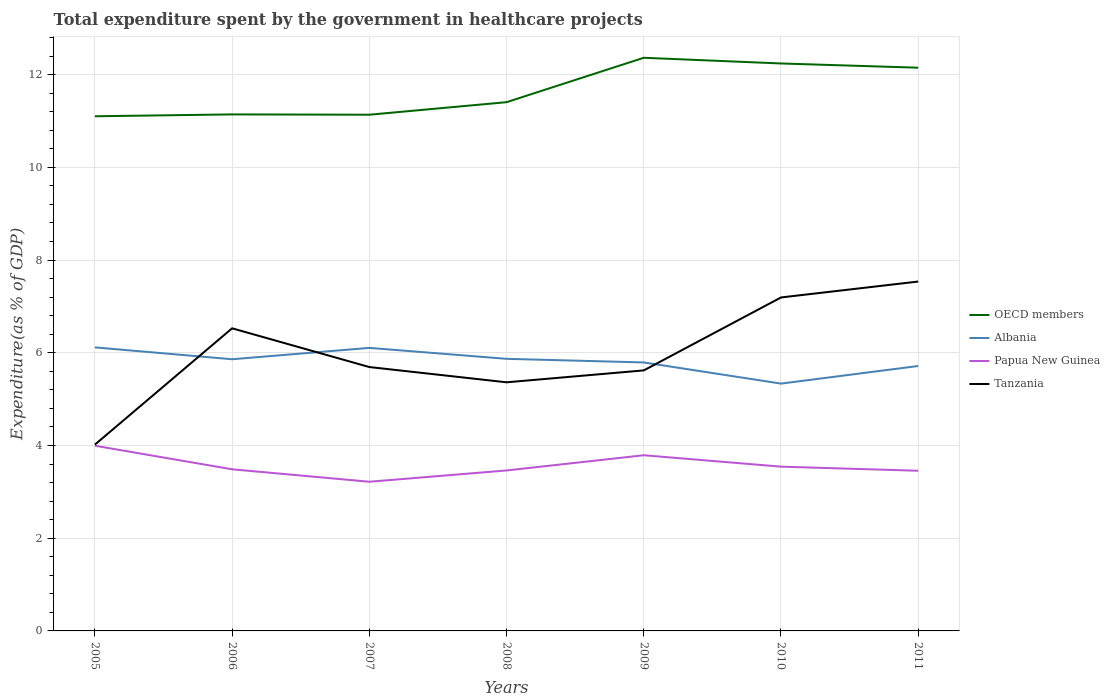How many different coloured lines are there?
Provide a succinct answer. 4. Does the line corresponding to Albania intersect with the line corresponding to Papua New Guinea?
Provide a succinct answer. No. Across all years, what is the maximum total expenditure spent by the government in healthcare projects in OECD members?
Offer a terse response. 11.1. In which year was the total expenditure spent by the government in healthcare projects in Tanzania maximum?
Provide a succinct answer. 2005. What is the total total expenditure spent by the government in healthcare projects in Papua New Guinea in the graph?
Make the answer very short. 0.27. What is the difference between the highest and the second highest total expenditure spent by the government in healthcare projects in Papua New Guinea?
Your response must be concise. 0.78. What is the difference between the highest and the lowest total expenditure spent by the government in healthcare projects in Albania?
Offer a terse response. 4. Is the total expenditure spent by the government in healthcare projects in Tanzania strictly greater than the total expenditure spent by the government in healthcare projects in Papua New Guinea over the years?
Your response must be concise. No. How many years are there in the graph?
Your answer should be very brief. 7. Does the graph contain any zero values?
Make the answer very short. No. Where does the legend appear in the graph?
Make the answer very short. Center right. How are the legend labels stacked?
Offer a terse response. Vertical. What is the title of the graph?
Provide a succinct answer. Total expenditure spent by the government in healthcare projects. Does "Guatemala" appear as one of the legend labels in the graph?
Your answer should be very brief. No. What is the label or title of the Y-axis?
Your answer should be very brief. Expenditure(as % of GDP). What is the Expenditure(as % of GDP) of OECD members in 2005?
Give a very brief answer. 11.1. What is the Expenditure(as % of GDP) of Albania in 2005?
Offer a very short reply. 6.12. What is the Expenditure(as % of GDP) in Papua New Guinea in 2005?
Your answer should be very brief. 3.99. What is the Expenditure(as % of GDP) in Tanzania in 2005?
Provide a short and direct response. 4.02. What is the Expenditure(as % of GDP) in OECD members in 2006?
Your answer should be very brief. 11.14. What is the Expenditure(as % of GDP) in Albania in 2006?
Ensure brevity in your answer.  5.86. What is the Expenditure(as % of GDP) in Papua New Guinea in 2006?
Provide a short and direct response. 3.49. What is the Expenditure(as % of GDP) in Tanzania in 2006?
Provide a succinct answer. 6.53. What is the Expenditure(as % of GDP) in OECD members in 2007?
Make the answer very short. 11.13. What is the Expenditure(as % of GDP) of Albania in 2007?
Give a very brief answer. 6.11. What is the Expenditure(as % of GDP) of Papua New Guinea in 2007?
Your response must be concise. 3.22. What is the Expenditure(as % of GDP) in Tanzania in 2007?
Provide a short and direct response. 5.69. What is the Expenditure(as % of GDP) in OECD members in 2008?
Your answer should be compact. 11.41. What is the Expenditure(as % of GDP) of Albania in 2008?
Your answer should be compact. 5.87. What is the Expenditure(as % of GDP) in Papua New Guinea in 2008?
Offer a very short reply. 3.46. What is the Expenditure(as % of GDP) of Tanzania in 2008?
Provide a short and direct response. 5.36. What is the Expenditure(as % of GDP) of OECD members in 2009?
Your answer should be compact. 12.36. What is the Expenditure(as % of GDP) of Albania in 2009?
Keep it short and to the point. 5.79. What is the Expenditure(as % of GDP) of Papua New Guinea in 2009?
Give a very brief answer. 3.79. What is the Expenditure(as % of GDP) in Tanzania in 2009?
Provide a succinct answer. 5.62. What is the Expenditure(as % of GDP) of OECD members in 2010?
Your answer should be very brief. 12.24. What is the Expenditure(as % of GDP) in Albania in 2010?
Make the answer very short. 5.34. What is the Expenditure(as % of GDP) of Papua New Guinea in 2010?
Keep it short and to the point. 3.54. What is the Expenditure(as % of GDP) in Tanzania in 2010?
Your answer should be very brief. 7.19. What is the Expenditure(as % of GDP) in OECD members in 2011?
Provide a succinct answer. 12.15. What is the Expenditure(as % of GDP) in Albania in 2011?
Your response must be concise. 5.71. What is the Expenditure(as % of GDP) of Papua New Guinea in 2011?
Offer a terse response. 3.46. What is the Expenditure(as % of GDP) of Tanzania in 2011?
Keep it short and to the point. 7.54. Across all years, what is the maximum Expenditure(as % of GDP) of OECD members?
Your response must be concise. 12.36. Across all years, what is the maximum Expenditure(as % of GDP) of Albania?
Give a very brief answer. 6.12. Across all years, what is the maximum Expenditure(as % of GDP) of Papua New Guinea?
Make the answer very short. 3.99. Across all years, what is the maximum Expenditure(as % of GDP) of Tanzania?
Your answer should be very brief. 7.54. Across all years, what is the minimum Expenditure(as % of GDP) of OECD members?
Offer a very short reply. 11.1. Across all years, what is the minimum Expenditure(as % of GDP) of Albania?
Offer a very short reply. 5.34. Across all years, what is the minimum Expenditure(as % of GDP) of Papua New Guinea?
Your answer should be compact. 3.22. Across all years, what is the minimum Expenditure(as % of GDP) of Tanzania?
Make the answer very short. 4.02. What is the total Expenditure(as % of GDP) in OECD members in the graph?
Give a very brief answer. 81.54. What is the total Expenditure(as % of GDP) in Albania in the graph?
Give a very brief answer. 40.79. What is the total Expenditure(as % of GDP) in Papua New Guinea in the graph?
Your response must be concise. 24.95. What is the total Expenditure(as % of GDP) in Tanzania in the graph?
Your response must be concise. 41.95. What is the difference between the Expenditure(as % of GDP) of OECD members in 2005 and that in 2006?
Your response must be concise. -0.04. What is the difference between the Expenditure(as % of GDP) of Albania in 2005 and that in 2006?
Your answer should be compact. 0.26. What is the difference between the Expenditure(as % of GDP) in Papua New Guinea in 2005 and that in 2006?
Make the answer very short. 0.51. What is the difference between the Expenditure(as % of GDP) in Tanzania in 2005 and that in 2006?
Give a very brief answer. -2.51. What is the difference between the Expenditure(as % of GDP) in OECD members in 2005 and that in 2007?
Provide a succinct answer. -0.03. What is the difference between the Expenditure(as % of GDP) of Albania in 2005 and that in 2007?
Provide a succinct answer. 0.01. What is the difference between the Expenditure(as % of GDP) in Papua New Guinea in 2005 and that in 2007?
Your answer should be very brief. 0.78. What is the difference between the Expenditure(as % of GDP) of Tanzania in 2005 and that in 2007?
Provide a short and direct response. -1.67. What is the difference between the Expenditure(as % of GDP) in OECD members in 2005 and that in 2008?
Your answer should be very brief. -0.3. What is the difference between the Expenditure(as % of GDP) in Albania in 2005 and that in 2008?
Provide a succinct answer. 0.25. What is the difference between the Expenditure(as % of GDP) in Papua New Guinea in 2005 and that in 2008?
Give a very brief answer. 0.53. What is the difference between the Expenditure(as % of GDP) of Tanzania in 2005 and that in 2008?
Keep it short and to the point. -1.34. What is the difference between the Expenditure(as % of GDP) of OECD members in 2005 and that in 2009?
Your answer should be compact. -1.26. What is the difference between the Expenditure(as % of GDP) in Albania in 2005 and that in 2009?
Your answer should be compact. 0.32. What is the difference between the Expenditure(as % of GDP) of Papua New Guinea in 2005 and that in 2009?
Your answer should be very brief. 0.21. What is the difference between the Expenditure(as % of GDP) in Tanzania in 2005 and that in 2009?
Your answer should be compact. -1.6. What is the difference between the Expenditure(as % of GDP) of OECD members in 2005 and that in 2010?
Make the answer very short. -1.14. What is the difference between the Expenditure(as % of GDP) in Albania in 2005 and that in 2010?
Offer a terse response. 0.78. What is the difference between the Expenditure(as % of GDP) in Papua New Guinea in 2005 and that in 2010?
Ensure brevity in your answer.  0.45. What is the difference between the Expenditure(as % of GDP) of Tanzania in 2005 and that in 2010?
Offer a very short reply. -3.17. What is the difference between the Expenditure(as % of GDP) in OECD members in 2005 and that in 2011?
Offer a very short reply. -1.05. What is the difference between the Expenditure(as % of GDP) in Albania in 2005 and that in 2011?
Keep it short and to the point. 0.4. What is the difference between the Expenditure(as % of GDP) in Papua New Guinea in 2005 and that in 2011?
Your answer should be very brief. 0.54. What is the difference between the Expenditure(as % of GDP) of Tanzania in 2005 and that in 2011?
Offer a very short reply. -3.52. What is the difference between the Expenditure(as % of GDP) of OECD members in 2006 and that in 2007?
Your answer should be compact. 0.01. What is the difference between the Expenditure(as % of GDP) in Albania in 2006 and that in 2007?
Your response must be concise. -0.24. What is the difference between the Expenditure(as % of GDP) in Papua New Guinea in 2006 and that in 2007?
Make the answer very short. 0.27. What is the difference between the Expenditure(as % of GDP) in Tanzania in 2006 and that in 2007?
Make the answer very short. 0.84. What is the difference between the Expenditure(as % of GDP) in OECD members in 2006 and that in 2008?
Offer a very short reply. -0.26. What is the difference between the Expenditure(as % of GDP) in Albania in 2006 and that in 2008?
Your answer should be very brief. -0.01. What is the difference between the Expenditure(as % of GDP) of Papua New Guinea in 2006 and that in 2008?
Provide a succinct answer. 0.03. What is the difference between the Expenditure(as % of GDP) in Tanzania in 2006 and that in 2008?
Ensure brevity in your answer.  1.16. What is the difference between the Expenditure(as % of GDP) in OECD members in 2006 and that in 2009?
Offer a terse response. -1.22. What is the difference between the Expenditure(as % of GDP) in Albania in 2006 and that in 2009?
Offer a terse response. 0.07. What is the difference between the Expenditure(as % of GDP) of Papua New Guinea in 2006 and that in 2009?
Give a very brief answer. -0.3. What is the difference between the Expenditure(as % of GDP) in Tanzania in 2006 and that in 2009?
Offer a very short reply. 0.91. What is the difference between the Expenditure(as % of GDP) in OECD members in 2006 and that in 2010?
Your answer should be very brief. -1.1. What is the difference between the Expenditure(as % of GDP) in Albania in 2006 and that in 2010?
Keep it short and to the point. 0.53. What is the difference between the Expenditure(as % of GDP) in Papua New Guinea in 2006 and that in 2010?
Make the answer very short. -0.06. What is the difference between the Expenditure(as % of GDP) of Tanzania in 2006 and that in 2010?
Offer a terse response. -0.67. What is the difference between the Expenditure(as % of GDP) in OECD members in 2006 and that in 2011?
Offer a terse response. -1.01. What is the difference between the Expenditure(as % of GDP) in Albania in 2006 and that in 2011?
Provide a succinct answer. 0.15. What is the difference between the Expenditure(as % of GDP) in Papua New Guinea in 2006 and that in 2011?
Offer a terse response. 0.03. What is the difference between the Expenditure(as % of GDP) of Tanzania in 2006 and that in 2011?
Your response must be concise. -1.01. What is the difference between the Expenditure(as % of GDP) in OECD members in 2007 and that in 2008?
Give a very brief answer. -0.27. What is the difference between the Expenditure(as % of GDP) in Albania in 2007 and that in 2008?
Give a very brief answer. 0.24. What is the difference between the Expenditure(as % of GDP) of Papua New Guinea in 2007 and that in 2008?
Your answer should be very brief. -0.24. What is the difference between the Expenditure(as % of GDP) of Tanzania in 2007 and that in 2008?
Your response must be concise. 0.33. What is the difference between the Expenditure(as % of GDP) of OECD members in 2007 and that in 2009?
Your answer should be compact. -1.23. What is the difference between the Expenditure(as % of GDP) of Albania in 2007 and that in 2009?
Ensure brevity in your answer.  0.31. What is the difference between the Expenditure(as % of GDP) of Papua New Guinea in 2007 and that in 2009?
Make the answer very short. -0.57. What is the difference between the Expenditure(as % of GDP) in Tanzania in 2007 and that in 2009?
Give a very brief answer. 0.07. What is the difference between the Expenditure(as % of GDP) in OECD members in 2007 and that in 2010?
Ensure brevity in your answer.  -1.11. What is the difference between the Expenditure(as % of GDP) in Albania in 2007 and that in 2010?
Provide a short and direct response. 0.77. What is the difference between the Expenditure(as % of GDP) of Papua New Guinea in 2007 and that in 2010?
Offer a terse response. -0.33. What is the difference between the Expenditure(as % of GDP) of Tanzania in 2007 and that in 2010?
Your response must be concise. -1.5. What is the difference between the Expenditure(as % of GDP) of OECD members in 2007 and that in 2011?
Ensure brevity in your answer.  -1.01. What is the difference between the Expenditure(as % of GDP) in Albania in 2007 and that in 2011?
Make the answer very short. 0.39. What is the difference between the Expenditure(as % of GDP) in Papua New Guinea in 2007 and that in 2011?
Offer a terse response. -0.24. What is the difference between the Expenditure(as % of GDP) of Tanzania in 2007 and that in 2011?
Ensure brevity in your answer.  -1.84. What is the difference between the Expenditure(as % of GDP) of OECD members in 2008 and that in 2009?
Your answer should be very brief. -0.96. What is the difference between the Expenditure(as % of GDP) in Albania in 2008 and that in 2009?
Give a very brief answer. 0.08. What is the difference between the Expenditure(as % of GDP) in Papua New Guinea in 2008 and that in 2009?
Your answer should be very brief. -0.33. What is the difference between the Expenditure(as % of GDP) in Tanzania in 2008 and that in 2009?
Ensure brevity in your answer.  -0.26. What is the difference between the Expenditure(as % of GDP) in OECD members in 2008 and that in 2010?
Give a very brief answer. -0.83. What is the difference between the Expenditure(as % of GDP) in Albania in 2008 and that in 2010?
Your answer should be very brief. 0.53. What is the difference between the Expenditure(as % of GDP) in Papua New Guinea in 2008 and that in 2010?
Your answer should be very brief. -0.08. What is the difference between the Expenditure(as % of GDP) in Tanzania in 2008 and that in 2010?
Offer a very short reply. -1.83. What is the difference between the Expenditure(as % of GDP) in OECD members in 2008 and that in 2011?
Ensure brevity in your answer.  -0.74. What is the difference between the Expenditure(as % of GDP) of Albania in 2008 and that in 2011?
Make the answer very short. 0.15. What is the difference between the Expenditure(as % of GDP) in Papua New Guinea in 2008 and that in 2011?
Provide a succinct answer. 0.01. What is the difference between the Expenditure(as % of GDP) in Tanzania in 2008 and that in 2011?
Your answer should be compact. -2.17. What is the difference between the Expenditure(as % of GDP) of OECD members in 2009 and that in 2010?
Ensure brevity in your answer.  0.12. What is the difference between the Expenditure(as % of GDP) in Albania in 2009 and that in 2010?
Your answer should be compact. 0.46. What is the difference between the Expenditure(as % of GDP) of Papua New Guinea in 2009 and that in 2010?
Your answer should be compact. 0.25. What is the difference between the Expenditure(as % of GDP) in Tanzania in 2009 and that in 2010?
Your response must be concise. -1.57. What is the difference between the Expenditure(as % of GDP) in OECD members in 2009 and that in 2011?
Provide a succinct answer. 0.21. What is the difference between the Expenditure(as % of GDP) of Albania in 2009 and that in 2011?
Keep it short and to the point. 0.08. What is the difference between the Expenditure(as % of GDP) in Papua New Guinea in 2009 and that in 2011?
Your answer should be very brief. 0.33. What is the difference between the Expenditure(as % of GDP) in Tanzania in 2009 and that in 2011?
Keep it short and to the point. -1.92. What is the difference between the Expenditure(as % of GDP) in OECD members in 2010 and that in 2011?
Offer a terse response. 0.09. What is the difference between the Expenditure(as % of GDP) in Albania in 2010 and that in 2011?
Make the answer very short. -0.38. What is the difference between the Expenditure(as % of GDP) in Papua New Guinea in 2010 and that in 2011?
Make the answer very short. 0.09. What is the difference between the Expenditure(as % of GDP) of Tanzania in 2010 and that in 2011?
Offer a terse response. -0.34. What is the difference between the Expenditure(as % of GDP) of OECD members in 2005 and the Expenditure(as % of GDP) of Albania in 2006?
Keep it short and to the point. 5.24. What is the difference between the Expenditure(as % of GDP) of OECD members in 2005 and the Expenditure(as % of GDP) of Papua New Guinea in 2006?
Offer a very short reply. 7.62. What is the difference between the Expenditure(as % of GDP) of OECD members in 2005 and the Expenditure(as % of GDP) of Tanzania in 2006?
Keep it short and to the point. 4.57. What is the difference between the Expenditure(as % of GDP) in Albania in 2005 and the Expenditure(as % of GDP) in Papua New Guinea in 2006?
Offer a terse response. 2.63. What is the difference between the Expenditure(as % of GDP) in Albania in 2005 and the Expenditure(as % of GDP) in Tanzania in 2006?
Provide a short and direct response. -0.41. What is the difference between the Expenditure(as % of GDP) in Papua New Guinea in 2005 and the Expenditure(as % of GDP) in Tanzania in 2006?
Your answer should be very brief. -2.53. What is the difference between the Expenditure(as % of GDP) of OECD members in 2005 and the Expenditure(as % of GDP) of Albania in 2007?
Keep it short and to the point. 5. What is the difference between the Expenditure(as % of GDP) in OECD members in 2005 and the Expenditure(as % of GDP) in Papua New Guinea in 2007?
Offer a very short reply. 7.88. What is the difference between the Expenditure(as % of GDP) of OECD members in 2005 and the Expenditure(as % of GDP) of Tanzania in 2007?
Your response must be concise. 5.41. What is the difference between the Expenditure(as % of GDP) in Albania in 2005 and the Expenditure(as % of GDP) in Papua New Guinea in 2007?
Keep it short and to the point. 2.9. What is the difference between the Expenditure(as % of GDP) of Albania in 2005 and the Expenditure(as % of GDP) of Tanzania in 2007?
Offer a very short reply. 0.42. What is the difference between the Expenditure(as % of GDP) of Papua New Guinea in 2005 and the Expenditure(as % of GDP) of Tanzania in 2007?
Make the answer very short. -1.7. What is the difference between the Expenditure(as % of GDP) in OECD members in 2005 and the Expenditure(as % of GDP) in Albania in 2008?
Provide a succinct answer. 5.23. What is the difference between the Expenditure(as % of GDP) in OECD members in 2005 and the Expenditure(as % of GDP) in Papua New Guinea in 2008?
Make the answer very short. 7.64. What is the difference between the Expenditure(as % of GDP) in OECD members in 2005 and the Expenditure(as % of GDP) in Tanzania in 2008?
Your answer should be compact. 5.74. What is the difference between the Expenditure(as % of GDP) of Albania in 2005 and the Expenditure(as % of GDP) of Papua New Guinea in 2008?
Make the answer very short. 2.65. What is the difference between the Expenditure(as % of GDP) of Albania in 2005 and the Expenditure(as % of GDP) of Tanzania in 2008?
Your answer should be very brief. 0.75. What is the difference between the Expenditure(as % of GDP) of Papua New Guinea in 2005 and the Expenditure(as % of GDP) of Tanzania in 2008?
Give a very brief answer. -1.37. What is the difference between the Expenditure(as % of GDP) of OECD members in 2005 and the Expenditure(as % of GDP) of Albania in 2009?
Offer a terse response. 5.31. What is the difference between the Expenditure(as % of GDP) of OECD members in 2005 and the Expenditure(as % of GDP) of Papua New Guinea in 2009?
Provide a short and direct response. 7.31. What is the difference between the Expenditure(as % of GDP) of OECD members in 2005 and the Expenditure(as % of GDP) of Tanzania in 2009?
Offer a very short reply. 5.48. What is the difference between the Expenditure(as % of GDP) in Albania in 2005 and the Expenditure(as % of GDP) in Papua New Guinea in 2009?
Your response must be concise. 2.33. What is the difference between the Expenditure(as % of GDP) of Albania in 2005 and the Expenditure(as % of GDP) of Tanzania in 2009?
Make the answer very short. 0.5. What is the difference between the Expenditure(as % of GDP) in Papua New Guinea in 2005 and the Expenditure(as % of GDP) in Tanzania in 2009?
Your answer should be compact. -1.62. What is the difference between the Expenditure(as % of GDP) of OECD members in 2005 and the Expenditure(as % of GDP) of Albania in 2010?
Offer a terse response. 5.77. What is the difference between the Expenditure(as % of GDP) of OECD members in 2005 and the Expenditure(as % of GDP) of Papua New Guinea in 2010?
Keep it short and to the point. 7.56. What is the difference between the Expenditure(as % of GDP) of OECD members in 2005 and the Expenditure(as % of GDP) of Tanzania in 2010?
Give a very brief answer. 3.91. What is the difference between the Expenditure(as % of GDP) in Albania in 2005 and the Expenditure(as % of GDP) in Papua New Guinea in 2010?
Keep it short and to the point. 2.57. What is the difference between the Expenditure(as % of GDP) of Albania in 2005 and the Expenditure(as % of GDP) of Tanzania in 2010?
Ensure brevity in your answer.  -1.08. What is the difference between the Expenditure(as % of GDP) of Papua New Guinea in 2005 and the Expenditure(as % of GDP) of Tanzania in 2010?
Ensure brevity in your answer.  -3.2. What is the difference between the Expenditure(as % of GDP) of OECD members in 2005 and the Expenditure(as % of GDP) of Albania in 2011?
Provide a succinct answer. 5.39. What is the difference between the Expenditure(as % of GDP) in OECD members in 2005 and the Expenditure(as % of GDP) in Papua New Guinea in 2011?
Your answer should be compact. 7.65. What is the difference between the Expenditure(as % of GDP) in OECD members in 2005 and the Expenditure(as % of GDP) in Tanzania in 2011?
Ensure brevity in your answer.  3.56. What is the difference between the Expenditure(as % of GDP) of Albania in 2005 and the Expenditure(as % of GDP) of Papua New Guinea in 2011?
Provide a succinct answer. 2.66. What is the difference between the Expenditure(as % of GDP) of Albania in 2005 and the Expenditure(as % of GDP) of Tanzania in 2011?
Make the answer very short. -1.42. What is the difference between the Expenditure(as % of GDP) in Papua New Guinea in 2005 and the Expenditure(as % of GDP) in Tanzania in 2011?
Make the answer very short. -3.54. What is the difference between the Expenditure(as % of GDP) of OECD members in 2006 and the Expenditure(as % of GDP) of Albania in 2007?
Offer a very short reply. 5.04. What is the difference between the Expenditure(as % of GDP) in OECD members in 2006 and the Expenditure(as % of GDP) in Papua New Guinea in 2007?
Your answer should be compact. 7.92. What is the difference between the Expenditure(as % of GDP) of OECD members in 2006 and the Expenditure(as % of GDP) of Tanzania in 2007?
Your answer should be compact. 5.45. What is the difference between the Expenditure(as % of GDP) in Albania in 2006 and the Expenditure(as % of GDP) in Papua New Guinea in 2007?
Offer a very short reply. 2.64. What is the difference between the Expenditure(as % of GDP) in Albania in 2006 and the Expenditure(as % of GDP) in Tanzania in 2007?
Ensure brevity in your answer.  0.17. What is the difference between the Expenditure(as % of GDP) of Papua New Guinea in 2006 and the Expenditure(as % of GDP) of Tanzania in 2007?
Make the answer very short. -2.21. What is the difference between the Expenditure(as % of GDP) of OECD members in 2006 and the Expenditure(as % of GDP) of Albania in 2008?
Offer a terse response. 5.27. What is the difference between the Expenditure(as % of GDP) of OECD members in 2006 and the Expenditure(as % of GDP) of Papua New Guinea in 2008?
Your answer should be compact. 7.68. What is the difference between the Expenditure(as % of GDP) in OECD members in 2006 and the Expenditure(as % of GDP) in Tanzania in 2008?
Ensure brevity in your answer.  5.78. What is the difference between the Expenditure(as % of GDP) in Albania in 2006 and the Expenditure(as % of GDP) in Papua New Guinea in 2008?
Your answer should be very brief. 2.4. What is the difference between the Expenditure(as % of GDP) in Albania in 2006 and the Expenditure(as % of GDP) in Tanzania in 2008?
Offer a terse response. 0.5. What is the difference between the Expenditure(as % of GDP) in Papua New Guinea in 2006 and the Expenditure(as % of GDP) in Tanzania in 2008?
Make the answer very short. -1.88. What is the difference between the Expenditure(as % of GDP) in OECD members in 2006 and the Expenditure(as % of GDP) in Albania in 2009?
Give a very brief answer. 5.35. What is the difference between the Expenditure(as % of GDP) in OECD members in 2006 and the Expenditure(as % of GDP) in Papua New Guinea in 2009?
Provide a succinct answer. 7.35. What is the difference between the Expenditure(as % of GDP) in OECD members in 2006 and the Expenditure(as % of GDP) in Tanzania in 2009?
Offer a very short reply. 5.52. What is the difference between the Expenditure(as % of GDP) of Albania in 2006 and the Expenditure(as % of GDP) of Papua New Guinea in 2009?
Ensure brevity in your answer.  2.07. What is the difference between the Expenditure(as % of GDP) in Albania in 2006 and the Expenditure(as % of GDP) in Tanzania in 2009?
Provide a succinct answer. 0.24. What is the difference between the Expenditure(as % of GDP) in Papua New Guinea in 2006 and the Expenditure(as % of GDP) in Tanzania in 2009?
Ensure brevity in your answer.  -2.13. What is the difference between the Expenditure(as % of GDP) of OECD members in 2006 and the Expenditure(as % of GDP) of Albania in 2010?
Give a very brief answer. 5.81. What is the difference between the Expenditure(as % of GDP) in OECD members in 2006 and the Expenditure(as % of GDP) in Papua New Guinea in 2010?
Provide a succinct answer. 7.6. What is the difference between the Expenditure(as % of GDP) in OECD members in 2006 and the Expenditure(as % of GDP) in Tanzania in 2010?
Provide a succinct answer. 3.95. What is the difference between the Expenditure(as % of GDP) of Albania in 2006 and the Expenditure(as % of GDP) of Papua New Guinea in 2010?
Ensure brevity in your answer.  2.32. What is the difference between the Expenditure(as % of GDP) of Albania in 2006 and the Expenditure(as % of GDP) of Tanzania in 2010?
Give a very brief answer. -1.33. What is the difference between the Expenditure(as % of GDP) of Papua New Guinea in 2006 and the Expenditure(as % of GDP) of Tanzania in 2010?
Give a very brief answer. -3.71. What is the difference between the Expenditure(as % of GDP) in OECD members in 2006 and the Expenditure(as % of GDP) in Albania in 2011?
Provide a succinct answer. 5.43. What is the difference between the Expenditure(as % of GDP) in OECD members in 2006 and the Expenditure(as % of GDP) in Papua New Guinea in 2011?
Give a very brief answer. 7.69. What is the difference between the Expenditure(as % of GDP) of OECD members in 2006 and the Expenditure(as % of GDP) of Tanzania in 2011?
Ensure brevity in your answer.  3.61. What is the difference between the Expenditure(as % of GDP) in Albania in 2006 and the Expenditure(as % of GDP) in Papua New Guinea in 2011?
Provide a succinct answer. 2.41. What is the difference between the Expenditure(as % of GDP) of Albania in 2006 and the Expenditure(as % of GDP) of Tanzania in 2011?
Provide a succinct answer. -1.68. What is the difference between the Expenditure(as % of GDP) of Papua New Guinea in 2006 and the Expenditure(as % of GDP) of Tanzania in 2011?
Provide a short and direct response. -4.05. What is the difference between the Expenditure(as % of GDP) of OECD members in 2007 and the Expenditure(as % of GDP) of Albania in 2008?
Keep it short and to the point. 5.27. What is the difference between the Expenditure(as % of GDP) in OECD members in 2007 and the Expenditure(as % of GDP) in Papua New Guinea in 2008?
Provide a succinct answer. 7.67. What is the difference between the Expenditure(as % of GDP) in OECD members in 2007 and the Expenditure(as % of GDP) in Tanzania in 2008?
Ensure brevity in your answer.  5.77. What is the difference between the Expenditure(as % of GDP) in Albania in 2007 and the Expenditure(as % of GDP) in Papua New Guinea in 2008?
Make the answer very short. 2.64. What is the difference between the Expenditure(as % of GDP) of Albania in 2007 and the Expenditure(as % of GDP) of Tanzania in 2008?
Your answer should be very brief. 0.74. What is the difference between the Expenditure(as % of GDP) in Papua New Guinea in 2007 and the Expenditure(as % of GDP) in Tanzania in 2008?
Make the answer very short. -2.15. What is the difference between the Expenditure(as % of GDP) of OECD members in 2007 and the Expenditure(as % of GDP) of Albania in 2009?
Offer a very short reply. 5.34. What is the difference between the Expenditure(as % of GDP) of OECD members in 2007 and the Expenditure(as % of GDP) of Papua New Guinea in 2009?
Your response must be concise. 7.35. What is the difference between the Expenditure(as % of GDP) of OECD members in 2007 and the Expenditure(as % of GDP) of Tanzania in 2009?
Ensure brevity in your answer.  5.52. What is the difference between the Expenditure(as % of GDP) of Albania in 2007 and the Expenditure(as % of GDP) of Papua New Guinea in 2009?
Your answer should be compact. 2.32. What is the difference between the Expenditure(as % of GDP) in Albania in 2007 and the Expenditure(as % of GDP) in Tanzania in 2009?
Ensure brevity in your answer.  0.49. What is the difference between the Expenditure(as % of GDP) in Papua New Guinea in 2007 and the Expenditure(as % of GDP) in Tanzania in 2009?
Provide a succinct answer. -2.4. What is the difference between the Expenditure(as % of GDP) of OECD members in 2007 and the Expenditure(as % of GDP) of Albania in 2010?
Make the answer very short. 5.8. What is the difference between the Expenditure(as % of GDP) in OECD members in 2007 and the Expenditure(as % of GDP) in Papua New Guinea in 2010?
Provide a short and direct response. 7.59. What is the difference between the Expenditure(as % of GDP) of OECD members in 2007 and the Expenditure(as % of GDP) of Tanzania in 2010?
Your answer should be very brief. 3.94. What is the difference between the Expenditure(as % of GDP) of Albania in 2007 and the Expenditure(as % of GDP) of Papua New Guinea in 2010?
Offer a terse response. 2.56. What is the difference between the Expenditure(as % of GDP) in Albania in 2007 and the Expenditure(as % of GDP) in Tanzania in 2010?
Keep it short and to the point. -1.09. What is the difference between the Expenditure(as % of GDP) in Papua New Guinea in 2007 and the Expenditure(as % of GDP) in Tanzania in 2010?
Keep it short and to the point. -3.98. What is the difference between the Expenditure(as % of GDP) in OECD members in 2007 and the Expenditure(as % of GDP) in Albania in 2011?
Keep it short and to the point. 5.42. What is the difference between the Expenditure(as % of GDP) of OECD members in 2007 and the Expenditure(as % of GDP) of Papua New Guinea in 2011?
Your answer should be very brief. 7.68. What is the difference between the Expenditure(as % of GDP) of OECD members in 2007 and the Expenditure(as % of GDP) of Tanzania in 2011?
Keep it short and to the point. 3.6. What is the difference between the Expenditure(as % of GDP) of Albania in 2007 and the Expenditure(as % of GDP) of Papua New Guinea in 2011?
Ensure brevity in your answer.  2.65. What is the difference between the Expenditure(as % of GDP) of Albania in 2007 and the Expenditure(as % of GDP) of Tanzania in 2011?
Your answer should be compact. -1.43. What is the difference between the Expenditure(as % of GDP) in Papua New Guinea in 2007 and the Expenditure(as % of GDP) in Tanzania in 2011?
Ensure brevity in your answer.  -4.32. What is the difference between the Expenditure(as % of GDP) of OECD members in 2008 and the Expenditure(as % of GDP) of Albania in 2009?
Offer a very short reply. 5.61. What is the difference between the Expenditure(as % of GDP) of OECD members in 2008 and the Expenditure(as % of GDP) of Papua New Guinea in 2009?
Your answer should be compact. 7.62. What is the difference between the Expenditure(as % of GDP) of OECD members in 2008 and the Expenditure(as % of GDP) of Tanzania in 2009?
Give a very brief answer. 5.79. What is the difference between the Expenditure(as % of GDP) in Albania in 2008 and the Expenditure(as % of GDP) in Papua New Guinea in 2009?
Provide a succinct answer. 2.08. What is the difference between the Expenditure(as % of GDP) in Albania in 2008 and the Expenditure(as % of GDP) in Tanzania in 2009?
Your answer should be compact. 0.25. What is the difference between the Expenditure(as % of GDP) of Papua New Guinea in 2008 and the Expenditure(as % of GDP) of Tanzania in 2009?
Provide a short and direct response. -2.16. What is the difference between the Expenditure(as % of GDP) of OECD members in 2008 and the Expenditure(as % of GDP) of Albania in 2010?
Your answer should be very brief. 6.07. What is the difference between the Expenditure(as % of GDP) in OECD members in 2008 and the Expenditure(as % of GDP) in Papua New Guinea in 2010?
Provide a succinct answer. 7.86. What is the difference between the Expenditure(as % of GDP) in OECD members in 2008 and the Expenditure(as % of GDP) in Tanzania in 2010?
Offer a very short reply. 4.21. What is the difference between the Expenditure(as % of GDP) of Albania in 2008 and the Expenditure(as % of GDP) of Papua New Guinea in 2010?
Offer a very short reply. 2.33. What is the difference between the Expenditure(as % of GDP) in Albania in 2008 and the Expenditure(as % of GDP) in Tanzania in 2010?
Ensure brevity in your answer.  -1.32. What is the difference between the Expenditure(as % of GDP) in Papua New Guinea in 2008 and the Expenditure(as % of GDP) in Tanzania in 2010?
Offer a very short reply. -3.73. What is the difference between the Expenditure(as % of GDP) in OECD members in 2008 and the Expenditure(as % of GDP) in Albania in 2011?
Offer a very short reply. 5.69. What is the difference between the Expenditure(as % of GDP) in OECD members in 2008 and the Expenditure(as % of GDP) in Papua New Guinea in 2011?
Give a very brief answer. 7.95. What is the difference between the Expenditure(as % of GDP) of OECD members in 2008 and the Expenditure(as % of GDP) of Tanzania in 2011?
Ensure brevity in your answer.  3.87. What is the difference between the Expenditure(as % of GDP) in Albania in 2008 and the Expenditure(as % of GDP) in Papua New Guinea in 2011?
Give a very brief answer. 2.41. What is the difference between the Expenditure(as % of GDP) in Albania in 2008 and the Expenditure(as % of GDP) in Tanzania in 2011?
Offer a very short reply. -1.67. What is the difference between the Expenditure(as % of GDP) in Papua New Guinea in 2008 and the Expenditure(as % of GDP) in Tanzania in 2011?
Your answer should be compact. -4.08. What is the difference between the Expenditure(as % of GDP) of OECD members in 2009 and the Expenditure(as % of GDP) of Albania in 2010?
Make the answer very short. 7.03. What is the difference between the Expenditure(as % of GDP) in OECD members in 2009 and the Expenditure(as % of GDP) in Papua New Guinea in 2010?
Offer a terse response. 8.82. What is the difference between the Expenditure(as % of GDP) in OECD members in 2009 and the Expenditure(as % of GDP) in Tanzania in 2010?
Make the answer very short. 5.17. What is the difference between the Expenditure(as % of GDP) of Albania in 2009 and the Expenditure(as % of GDP) of Papua New Guinea in 2010?
Provide a succinct answer. 2.25. What is the difference between the Expenditure(as % of GDP) in Albania in 2009 and the Expenditure(as % of GDP) in Tanzania in 2010?
Your answer should be very brief. -1.4. What is the difference between the Expenditure(as % of GDP) of Papua New Guinea in 2009 and the Expenditure(as % of GDP) of Tanzania in 2010?
Ensure brevity in your answer.  -3.4. What is the difference between the Expenditure(as % of GDP) in OECD members in 2009 and the Expenditure(as % of GDP) in Albania in 2011?
Your answer should be compact. 6.65. What is the difference between the Expenditure(as % of GDP) in OECD members in 2009 and the Expenditure(as % of GDP) in Papua New Guinea in 2011?
Your answer should be very brief. 8.91. What is the difference between the Expenditure(as % of GDP) in OECD members in 2009 and the Expenditure(as % of GDP) in Tanzania in 2011?
Provide a succinct answer. 4.83. What is the difference between the Expenditure(as % of GDP) of Albania in 2009 and the Expenditure(as % of GDP) of Papua New Guinea in 2011?
Give a very brief answer. 2.34. What is the difference between the Expenditure(as % of GDP) in Albania in 2009 and the Expenditure(as % of GDP) in Tanzania in 2011?
Provide a succinct answer. -1.75. What is the difference between the Expenditure(as % of GDP) of Papua New Guinea in 2009 and the Expenditure(as % of GDP) of Tanzania in 2011?
Your answer should be very brief. -3.75. What is the difference between the Expenditure(as % of GDP) in OECD members in 2010 and the Expenditure(as % of GDP) in Albania in 2011?
Give a very brief answer. 6.53. What is the difference between the Expenditure(as % of GDP) in OECD members in 2010 and the Expenditure(as % of GDP) in Papua New Guinea in 2011?
Offer a very short reply. 8.79. What is the difference between the Expenditure(as % of GDP) of OECD members in 2010 and the Expenditure(as % of GDP) of Tanzania in 2011?
Your answer should be compact. 4.7. What is the difference between the Expenditure(as % of GDP) of Albania in 2010 and the Expenditure(as % of GDP) of Papua New Guinea in 2011?
Offer a terse response. 1.88. What is the difference between the Expenditure(as % of GDP) of Albania in 2010 and the Expenditure(as % of GDP) of Tanzania in 2011?
Make the answer very short. -2.2. What is the difference between the Expenditure(as % of GDP) in Papua New Guinea in 2010 and the Expenditure(as % of GDP) in Tanzania in 2011?
Your answer should be compact. -3.99. What is the average Expenditure(as % of GDP) of OECD members per year?
Your answer should be very brief. 11.65. What is the average Expenditure(as % of GDP) in Albania per year?
Offer a very short reply. 5.83. What is the average Expenditure(as % of GDP) in Papua New Guinea per year?
Make the answer very short. 3.56. What is the average Expenditure(as % of GDP) of Tanzania per year?
Your answer should be compact. 5.99. In the year 2005, what is the difference between the Expenditure(as % of GDP) of OECD members and Expenditure(as % of GDP) of Albania?
Your response must be concise. 4.99. In the year 2005, what is the difference between the Expenditure(as % of GDP) of OECD members and Expenditure(as % of GDP) of Papua New Guinea?
Keep it short and to the point. 7.11. In the year 2005, what is the difference between the Expenditure(as % of GDP) of OECD members and Expenditure(as % of GDP) of Tanzania?
Provide a short and direct response. 7.08. In the year 2005, what is the difference between the Expenditure(as % of GDP) of Albania and Expenditure(as % of GDP) of Papua New Guinea?
Give a very brief answer. 2.12. In the year 2005, what is the difference between the Expenditure(as % of GDP) in Albania and Expenditure(as % of GDP) in Tanzania?
Offer a very short reply. 2.1. In the year 2005, what is the difference between the Expenditure(as % of GDP) in Papua New Guinea and Expenditure(as % of GDP) in Tanzania?
Offer a terse response. -0.02. In the year 2006, what is the difference between the Expenditure(as % of GDP) in OECD members and Expenditure(as % of GDP) in Albania?
Offer a very short reply. 5.28. In the year 2006, what is the difference between the Expenditure(as % of GDP) of OECD members and Expenditure(as % of GDP) of Papua New Guinea?
Provide a succinct answer. 7.66. In the year 2006, what is the difference between the Expenditure(as % of GDP) in OECD members and Expenditure(as % of GDP) in Tanzania?
Ensure brevity in your answer.  4.61. In the year 2006, what is the difference between the Expenditure(as % of GDP) of Albania and Expenditure(as % of GDP) of Papua New Guinea?
Make the answer very short. 2.37. In the year 2006, what is the difference between the Expenditure(as % of GDP) of Albania and Expenditure(as % of GDP) of Tanzania?
Your answer should be compact. -0.67. In the year 2006, what is the difference between the Expenditure(as % of GDP) in Papua New Guinea and Expenditure(as % of GDP) in Tanzania?
Ensure brevity in your answer.  -3.04. In the year 2007, what is the difference between the Expenditure(as % of GDP) of OECD members and Expenditure(as % of GDP) of Albania?
Give a very brief answer. 5.03. In the year 2007, what is the difference between the Expenditure(as % of GDP) in OECD members and Expenditure(as % of GDP) in Papua New Guinea?
Provide a succinct answer. 7.92. In the year 2007, what is the difference between the Expenditure(as % of GDP) in OECD members and Expenditure(as % of GDP) in Tanzania?
Provide a short and direct response. 5.44. In the year 2007, what is the difference between the Expenditure(as % of GDP) in Albania and Expenditure(as % of GDP) in Papua New Guinea?
Your answer should be compact. 2.89. In the year 2007, what is the difference between the Expenditure(as % of GDP) in Albania and Expenditure(as % of GDP) in Tanzania?
Give a very brief answer. 0.41. In the year 2007, what is the difference between the Expenditure(as % of GDP) in Papua New Guinea and Expenditure(as % of GDP) in Tanzania?
Keep it short and to the point. -2.47. In the year 2008, what is the difference between the Expenditure(as % of GDP) in OECD members and Expenditure(as % of GDP) in Albania?
Your response must be concise. 5.54. In the year 2008, what is the difference between the Expenditure(as % of GDP) of OECD members and Expenditure(as % of GDP) of Papua New Guinea?
Keep it short and to the point. 7.94. In the year 2008, what is the difference between the Expenditure(as % of GDP) of OECD members and Expenditure(as % of GDP) of Tanzania?
Ensure brevity in your answer.  6.04. In the year 2008, what is the difference between the Expenditure(as % of GDP) of Albania and Expenditure(as % of GDP) of Papua New Guinea?
Provide a short and direct response. 2.41. In the year 2008, what is the difference between the Expenditure(as % of GDP) in Albania and Expenditure(as % of GDP) in Tanzania?
Make the answer very short. 0.51. In the year 2008, what is the difference between the Expenditure(as % of GDP) in Papua New Guinea and Expenditure(as % of GDP) in Tanzania?
Ensure brevity in your answer.  -1.9. In the year 2009, what is the difference between the Expenditure(as % of GDP) in OECD members and Expenditure(as % of GDP) in Albania?
Offer a terse response. 6.57. In the year 2009, what is the difference between the Expenditure(as % of GDP) of OECD members and Expenditure(as % of GDP) of Papua New Guinea?
Provide a short and direct response. 8.57. In the year 2009, what is the difference between the Expenditure(as % of GDP) of OECD members and Expenditure(as % of GDP) of Tanzania?
Your answer should be very brief. 6.74. In the year 2009, what is the difference between the Expenditure(as % of GDP) in Albania and Expenditure(as % of GDP) in Papua New Guinea?
Ensure brevity in your answer.  2. In the year 2009, what is the difference between the Expenditure(as % of GDP) in Albania and Expenditure(as % of GDP) in Tanzania?
Your answer should be compact. 0.17. In the year 2009, what is the difference between the Expenditure(as % of GDP) of Papua New Guinea and Expenditure(as % of GDP) of Tanzania?
Ensure brevity in your answer.  -1.83. In the year 2010, what is the difference between the Expenditure(as % of GDP) in OECD members and Expenditure(as % of GDP) in Albania?
Ensure brevity in your answer.  6.91. In the year 2010, what is the difference between the Expenditure(as % of GDP) of OECD members and Expenditure(as % of GDP) of Papua New Guinea?
Offer a very short reply. 8.7. In the year 2010, what is the difference between the Expenditure(as % of GDP) of OECD members and Expenditure(as % of GDP) of Tanzania?
Your answer should be compact. 5.05. In the year 2010, what is the difference between the Expenditure(as % of GDP) in Albania and Expenditure(as % of GDP) in Papua New Guinea?
Your answer should be very brief. 1.79. In the year 2010, what is the difference between the Expenditure(as % of GDP) in Albania and Expenditure(as % of GDP) in Tanzania?
Your answer should be very brief. -1.86. In the year 2010, what is the difference between the Expenditure(as % of GDP) of Papua New Guinea and Expenditure(as % of GDP) of Tanzania?
Your answer should be compact. -3.65. In the year 2011, what is the difference between the Expenditure(as % of GDP) in OECD members and Expenditure(as % of GDP) in Albania?
Give a very brief answer. 6.43. In the year 2011, what is the difference between the Expenditure(as % of GDP) of OECD members and Expenditure(as % of GDP) of Papua New Guinea?
Make the answer very short. 8.69. In the year 2011, what is the difference between the Expenditure(as % of GDP) of OECD members and Expenditure(as % of GDP) of Tanzania?
Your answer should be compact. 4.61. In the year 2011, what is the difference between the Expenditure(as % of GDP) in Albania and Expenditure(as % of GDP) in Papua New Guinea?
Your answer should be very brief. 2.26. In the year 2011, what is the difference between the Expenditure(as % of GDP) in Albania and Expenditure(as % of GDP) in Tanzania?
Offer a very short reply. -1.82. In the year 2011, what is the difference between the Expenditure(as % of GDP) in Papua New Guinea and Expenditure(as % of GDP) in Tanzania?
Your response must be concise. -4.08. What is the ratio of the Expenditure(as % of GDP) of OECD members in 2005 to that in 2006?
Make the answer very short. 1. What is the ratio of the Expenditure(as % of GDP) in Albania in 2005 to that in 2006?
Your response must be concise. 1.04. What is the ratio of the Expenditure(as % of GDP) of Papua New Guinea in 2005 to that in 2006?
Make the answer very short. 1.15. What is the ratio of the Expenditure(as % of GDP) of Tanzania in 2005 to that in 2006?
Keep it short and to the point. 0.62. What is the ratio of the Expenditure(as % of GDP) of OECD members in 2005 to that in 2007?
Offer a terse response. 1. What is the ratio of the Expenditure(as % of GDP) of Albania in 2005 to that in 2007?
Offer a very short reply. 1. What is the ratio of the Expenditure(as % of GDP) of Papua New Guinea in 2005 to that in 2007?
Your answer should be very brief. 1.24. What is the ratio of the Expenditure(as % of GDP) of Tanzania in 2005 to that in 2007?
Provide a short and direct response. 0.71. What is the ratio of the Expenditure(as % of GDP) in OECD members in 2005 to that in 2008?
Your answer should be compact. 0.97. What is the ratio of the Expenditure(as % of GDP) of Albania in 2005 to that in 2008?
Offer a terse response. 1.04. What is the ratio of the Expenditure(as % of GDP) in Papua New Guinea in 2005 to that in 2008?
Your answer should be very brief. 1.15. What is the ratio of the Expenditure(as % of GDP) in Tanzania in 2005 to that in 2008?
Offer a terse response. 0.75. What is the ratio of the Expenditure(as % of GDP) of OECD members in 2005 to that in 2009?
Ensure brevity in your answer.  0.9. What is the ratio of the Expenditure(as % of GDP) of Albania in 2005 to that in 2009?
Your answer should be compact. 1.06. What is the ratio of the Expenditure(as % of GDP) of Papua New Guinea in 2005 to that in 2009?
Offer a terse response. 1.05. What is the ratio of the Expenditure(as % of GDP) in Tanzania in 2005 to that in 2009?
Provide a succinct answer. 0.72. What is the ratio of the Expenditure(as % of GDP) of OECD members in 2005 to that in 2010?
Give a very brief answer. 0.91. What is the ratio of the Expenditure(as % of GDP) of Albania in 2005 to that in 2010?
Offer a very short reply. 1.15. What is the ratio of the Expenditure(as % of GDP) of Papua New Guinea in 2005 to that in 2010?
Ensure brevity in your answer.  1.13. What is the ratio of the Expenditure(as % of GDP) of Tanzania in 2005 to that in 2010?
Ensure brevity in your answer.  0.56. What is the ratio of the Expenditure(as % of GDP) in OECD members in 2005 to that in 2011?
Offer a terse response. 0.91. What is the ratio of the Expenditure(as % of GDP) in Albania in 2005 to that in 2011?
Offer a terse response. 1.07. What is the ratio of the Expenditure(as % of GDP) of Papua New Guinea in 2005 to that in 2011?
Provide a succinct answer. 1.16. What is the ratio of the Expenditure(as % of GDP) of Tanzania in 2005 to that in 2011?
Provide a succinct answer. 0.53. What is the ratio of the Expenditure(as % of GDP) of OECD members in 2006 to that in 2007?
Offer a terse response. 1. What is the ratio of the Expenditure(as % of GDP) in Albania in 2006 to that in 2007?
Offer a very short reply. 0.96. What is the ratio of the Expenditure(as % of GDP) in Papua New Guinea in 2006 to that in 2007?
Provide a succinct answer. 1.08. What is the ratio of the Expenditure(as % of GDP) of Tanzania in 2006 to that in 2007?
Provide a succinct answer. 1.15. What is the ratio of the Expenditure(as % of GDP) in OECD members in 2006 to that in 2008?
Your response must be concise. 0.98. What is the ratio of the Expenditure(as % of GDP) of Albania in 2006 to that in 2008?
Keep it short and to the point. 1. What is the ratio of the Expenditure(as % of GDP) of Tanzania in 2006 to that in 2008?
Ensure brevity in your answer.  1.22. What is the ratio of the Expenditure(as % of GDP) in OECD members in 2006 to that in 2009?
Offer a very short reply. 0.9. What is the ratio of the Expenditure(as % of GDP) of Albania in 2006 to that in 2009?
Make the answer very short. 1.01. What is the ratio of the Expenditure(as % of GDP) in Papua New Guinea in 2006 to that in 2009?
Your answer should be compact. 0.92. What is the ratio of the Expenditure(as % of GDP) in Tanzania in 2006 to that in 2009?
Provide a succinct answer. 1.16. What is the ratio of the Expenditure(as % of GDP) of OECD members in 2006 to that in 2010?
Ensure brevity in your answer.  0.91. What is the ratio of the Expenditure(as % of GDP) in Albania in 2006 to that in 2010?
Make the answer very short. 1.1. What is the ratio of the Expenditure(as % of GDP) in Papua New Guinea in 2006 to that in 2010?
Provide a succinct answer. 0.98. What is the ratio of the Expenditure(as % of GDP) in Tanzania in 2006 to that in 2010?
Provide a succinct answer. 0.91. What is the ratio of the Expenditure(as % of GDP) in OECD members in 2006 to that in 2011?
Your answer should be very brief. 0.92. What is the ratio of the Expenditure(as % of GDP) in Albania in 2006 to that in 2011?
Provide a short and direct response. 1.03. What is the ratio of the Expenditure(as % of GDP) of Papua New Guinea in 2006 to that in 2011?
Offer a very short reply. 1.01. What is the ratio of the Expenditure(as % of GDP) in Tanzania in 2006 to that in 2011?
Keep it short and to the point. 0.87. What is the ratio of the Expenditure(as % of GDP) of OECD members in 2007 to that in 2008?
Ensure brevity in your answer.  0.98. What is the ratio of the Expenditure(as % of GDP) of Albania in 2007 to that in 2008?
Your answer should be compact. 1.04. What is the ratio of the Expenditure(as % of GDP) of Papua New Guinea in 2007 to that in 2008?
Your answer should be compact. 0.93. What is the ratio of the Expenditure(as % of GDP) of Tanzania in 2007 to that in 2008?
Your answer should be compact. 1.06. What is the ratio of the Expenditure(as % of GDP) in OECD members in 2007 to that in 2009?
Ensure brevity in your answer.  0.9. What is the ratio of the Expenditure(as % of GDP) in Albania in 2007 to that in 2009?
Provide a succinct answer. 1.05. What is the ratio of the Expenditure(as % of GDP) of Papua New Guinea in 2007 to that in 2009?
Provide a succinct answer. 0.85. What is the ratio of the Expenditure(as % of GDP) in Tanzania in 2007 to that in 2009?
Your answer should be compact. 1.01. What is the ratio of the Expenditure(as % of GDP) of OECD members in 2007 to that in 2010?
Ensure brevity in your answer.  0.91. What is the ratio of the Expenditure(as % of GDP) in Albania in 2007 to that in 2010?
Provide a short and direct response. 1.14. What is the ratio of the Expenditure(as % of GDP) in Papua New Guinea in 2007 to that in 2010?
Provide a succinct answer. 0.91. What is the ratio of the Expenditure(as % of GDP) of Tanzania in 2007 to that in 2010?
Make the answer very short. 0.79. What is the ratio of the Expenditure(as % of GDP) in OECD members in 2007 to that in 2011?
Give a very brief answer. 0.92. What is the ratio of the Expenditure(as % of GDP) of Albania in 2007 to that in 2011?
Ensure brevity in your answer.  1.07. What is the ratio of the Expenditure(as % of GDP) of Papua New Guinea in 2007 to that in 2011?
Your response must be concise. 0.93. What is the ratio of the Expenditure(as % of GDP) of Tanzania in 2007 to that in 2011?
Ensure brevity in your answer.  0.76. What is the ratio of the Expenditure(as % of GDP) in OECD members in 2008 to that in 2009?
Your answer should be compact. 0.92. What is the ratio of the Expenditure(as % of GDP) in Albania in 2008 to that in 2009?
Offer a terse response. 1.01. What is the ratio of the Expenditure(as % of GDP) of Papua New Guinea in 2008 to that in 2009?
Keep it short and to the point. 0.91. What is the ratio of the Expenditure(as % of GDP) of Tanzania in 2008 to that in 2009?
Your response must be concise. 0.95. What is the ratio of the Expenditure(as % of GDP) of OECD members in 2008 to that in 2010?
Offer a terse response. 0.93. What is the ratio of the Expenditure(as % of GDP) in Albania in 2008 to that in 2010?
Make the answer very short. 1.1. What is the ratio of the Expenditure(as % of GDP) of Papua New Guinea in 2008 to that in 2010?
Give a very brief answer. 0.98. What is the ratio of the Expenditure(as % of GDP) of Tanzania in 2008 to that in 2010?
Your answer should be very brief. 0.75. What is the ratio of the Expenditure(as % of GDP) in OECD members in 2008 to that in 2011?
Your answer should be compact. 0.94. What is the ratio of the Expenditure(as % of GDP) in Albania in 2008 to that in 2011?
Make the answer very short. 1.03. What is the ratio of the Expenditure(as % of GDP) in Tanzania in 2008 to that in 2011?
Offer a terse response. 0.71. What is the ratio of the Expenditure(as % of GDP) of OECD members in 2009 to that in 2010?
Your answer should be compact. 1.01. What is the ratio of the Expenditure(as % of GDP) in Albania in 2009 to that in 2010?
Offer a very short reply. 1.09. What is the ratio of the Expenditure(as % of GDP) of Papua New Guinea in 2009 to that in 2010?
Your answer should be compact. 1.07. What is the ratio of the Expenditure(as % of GDP) of Tanzania in 2009 to that in 2010?
Give a very brief answer. 0.78. What is the ratio of the Expenditure(as % of GDP) of OECD members in 2009 to that in 2011?
Give a very brief answer. 1.02. What is the ratio of the Expenditure(as % of GDP) of Albania in 2009 to that in 2011?
Your response must be concise. 1.01. What is the ratio of the Expenditure(as % of GDP) in Papua New Guinea in 2009 to that in 2011?
Offer a terse response. 1.1. What is the ratio of the Expenditure(as % of GDP) of Tanzania in 2009 to that in 2011?
Give a very brief answer. 0.75. What is the ratio of the Expenditure(as % of GDP) in OECD members in 2010 to that in 2011?
Your response must be concise. 1.01. What is the ratio of the Expenditure(as % of GDP) in Albania in 2010 to that in 2011?
Ensure brevity in your answer.  0.93. What is the ratio of the Expenditure(as % of GDP) of Papua New Guinea in 2010 to that in 2011?
Provide a succinct answer. 1.03. What is the ratio of the Expenditure(as % of GDP) in Tanzania in 2010 to that in 2011?
Offer a terse response. 0.95. What is the difference between the highest and the second highest Expenditure(as % of GDP) of OECD members?
Make the answer very short. 0.12. What is the difference between the highest and the second highest Expenditure(as % of GDP) in Albania?
Your answer should be very brief. 0.01. What is the difference between the highest and the second highest Expenditure(as % of GDP) in Papua New Guinea?
Provide a succinct answer. 0.21. What is the difference between the highest and the second highest Expenditure(as % of GDP) of Tanzania?
Provide a succinct answer. 0.34. What is the difference between the highest and the lowest Expenditure(as % of GDP) of OECD members?
Your answer should be very brief. 1.26. What is the difference between the highest and the lowest Expenditure(as % of GDP) in Albania?
Provide a succinct answer. 0.78. What is the difference between the highest and the lowest Expenditure(as % of GDP) in Papua New Guinea?
Your answer should be very brief. 0.78. What is the difference between the highest and the lowest Expenditure(as % of GDP) of Tanzania?
Provide a short and direct response. 3.52. 